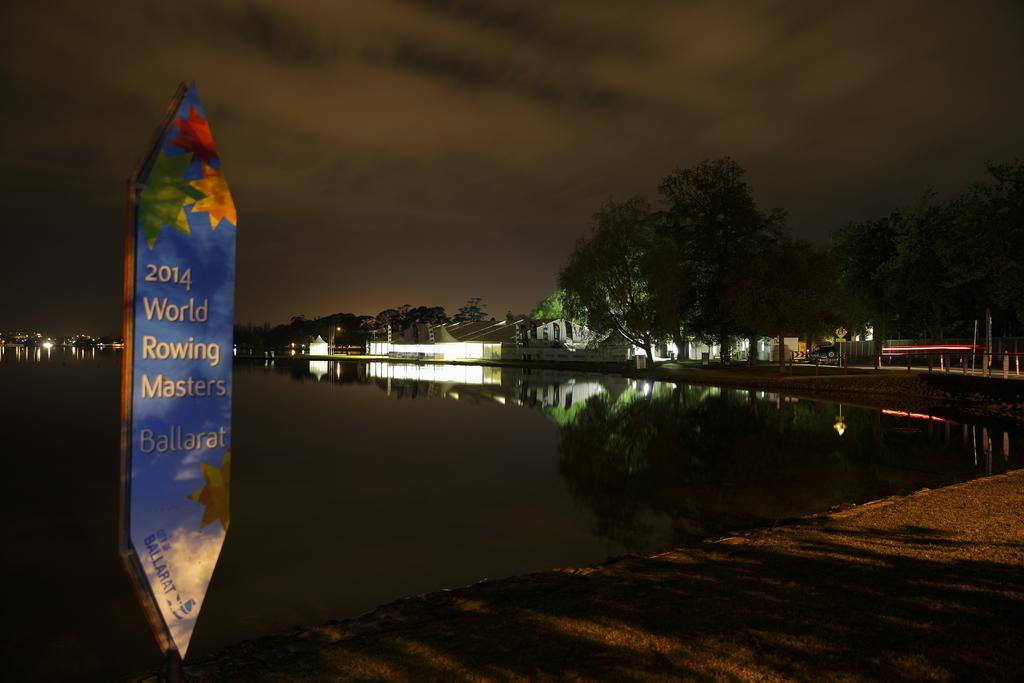What type of surface can be seen in the image? There is ground visible in the image. What object is present in the image? There is a board in the image. What natural element is visible in the image? There is water visible in the image. What type of structures can be seen in the background of the image? There are buildings and poles in the background of the image. What type of illumination is present in the background of the image? There are lights in the background of the image. What type of vehicle is visible in the background of the image? There is a car on the road in the background of the image. What type of vegetation is visible in the background of the image? There are trees in the background of the image. What is the color of the sky in the background of the image? The sky is dark in the background of the image. What is the profit margin of the tree in the image? There is no tree present in the image, and therefore no profit margin can be determined. 